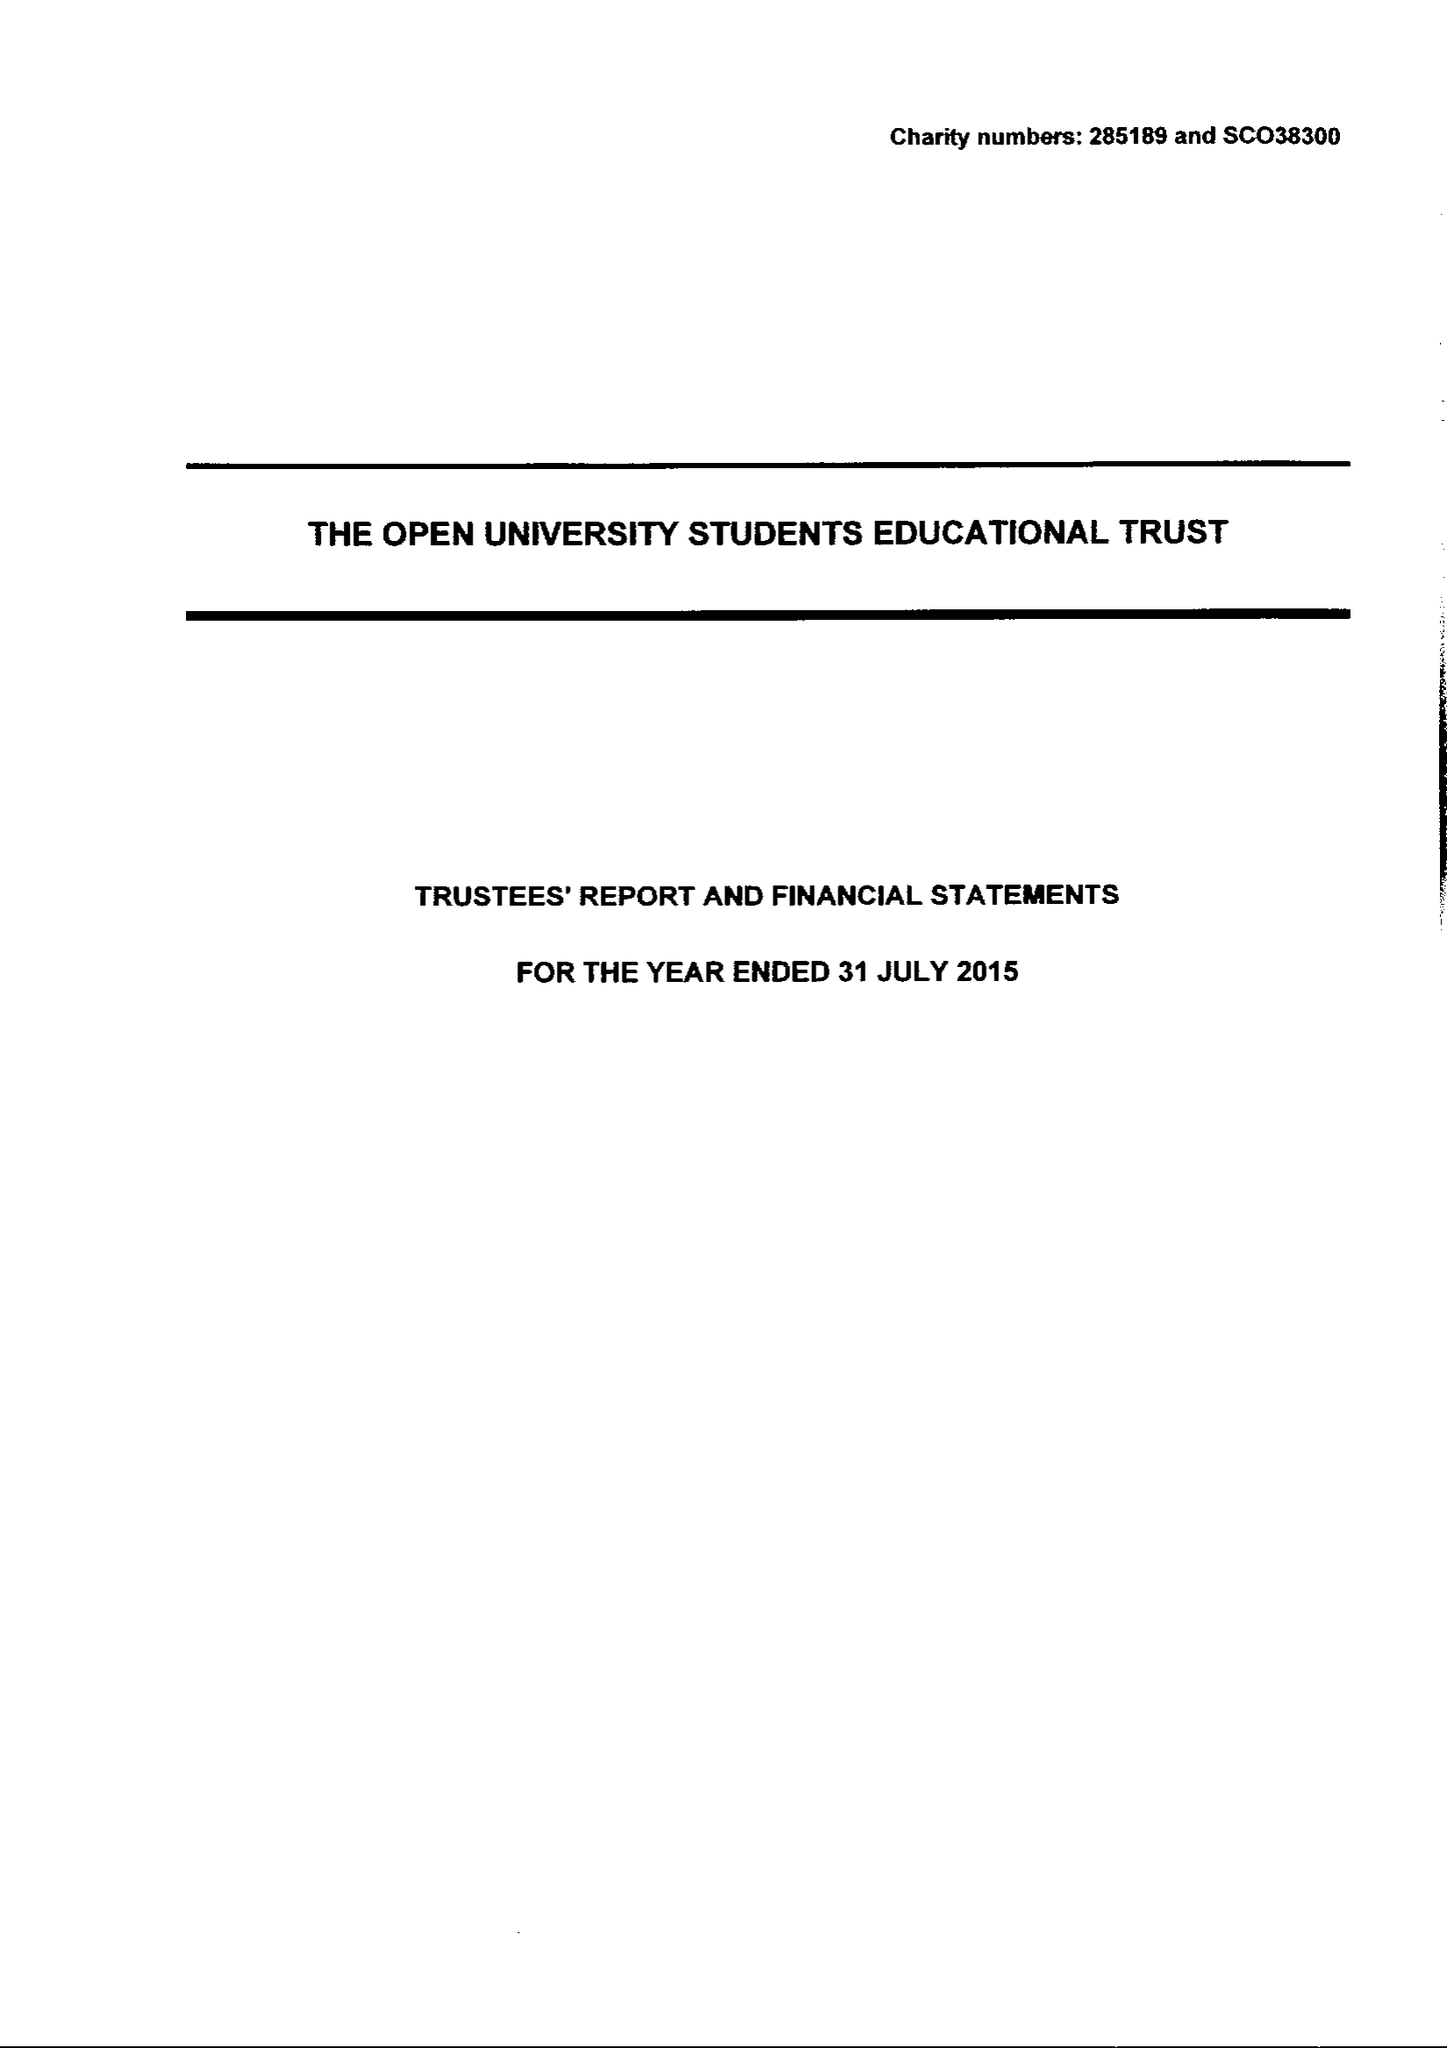What is the value for the report_date?
Answer the question using a single word or phrase. 2015-07-31 